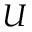Convert formula to latex. <formula><loc_0><loc_0><loc_500><loc_500>U</formula> 